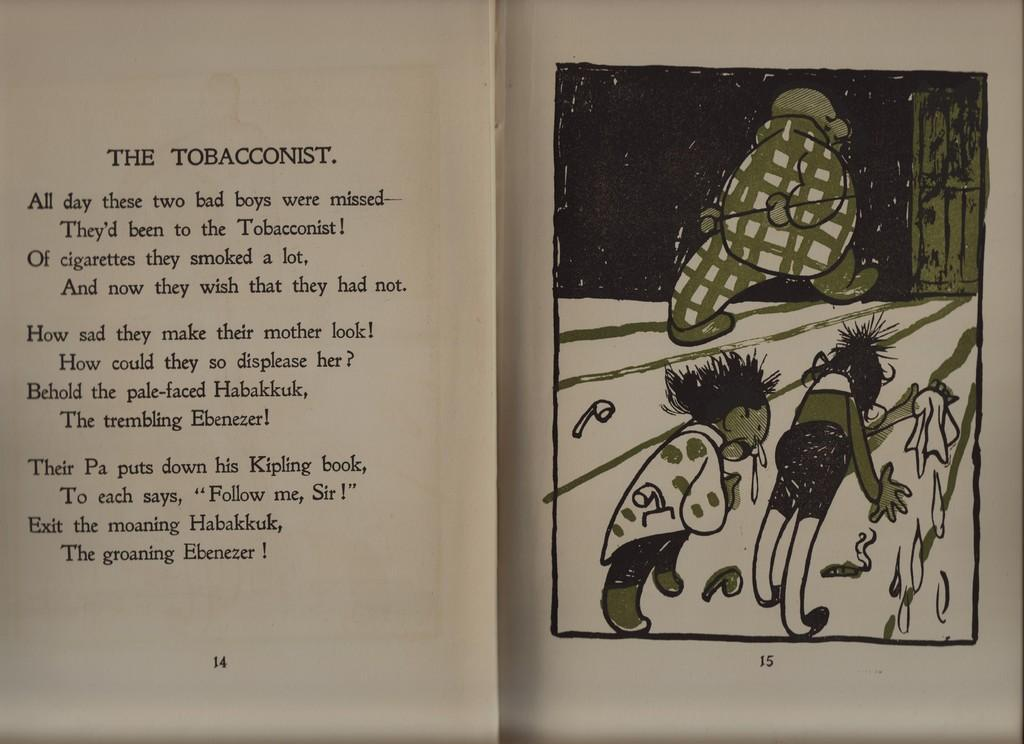<image>
Summarize the visual content of the image. A book opened up with the story title, The Tobacconist on the left page and an image on the right page. 